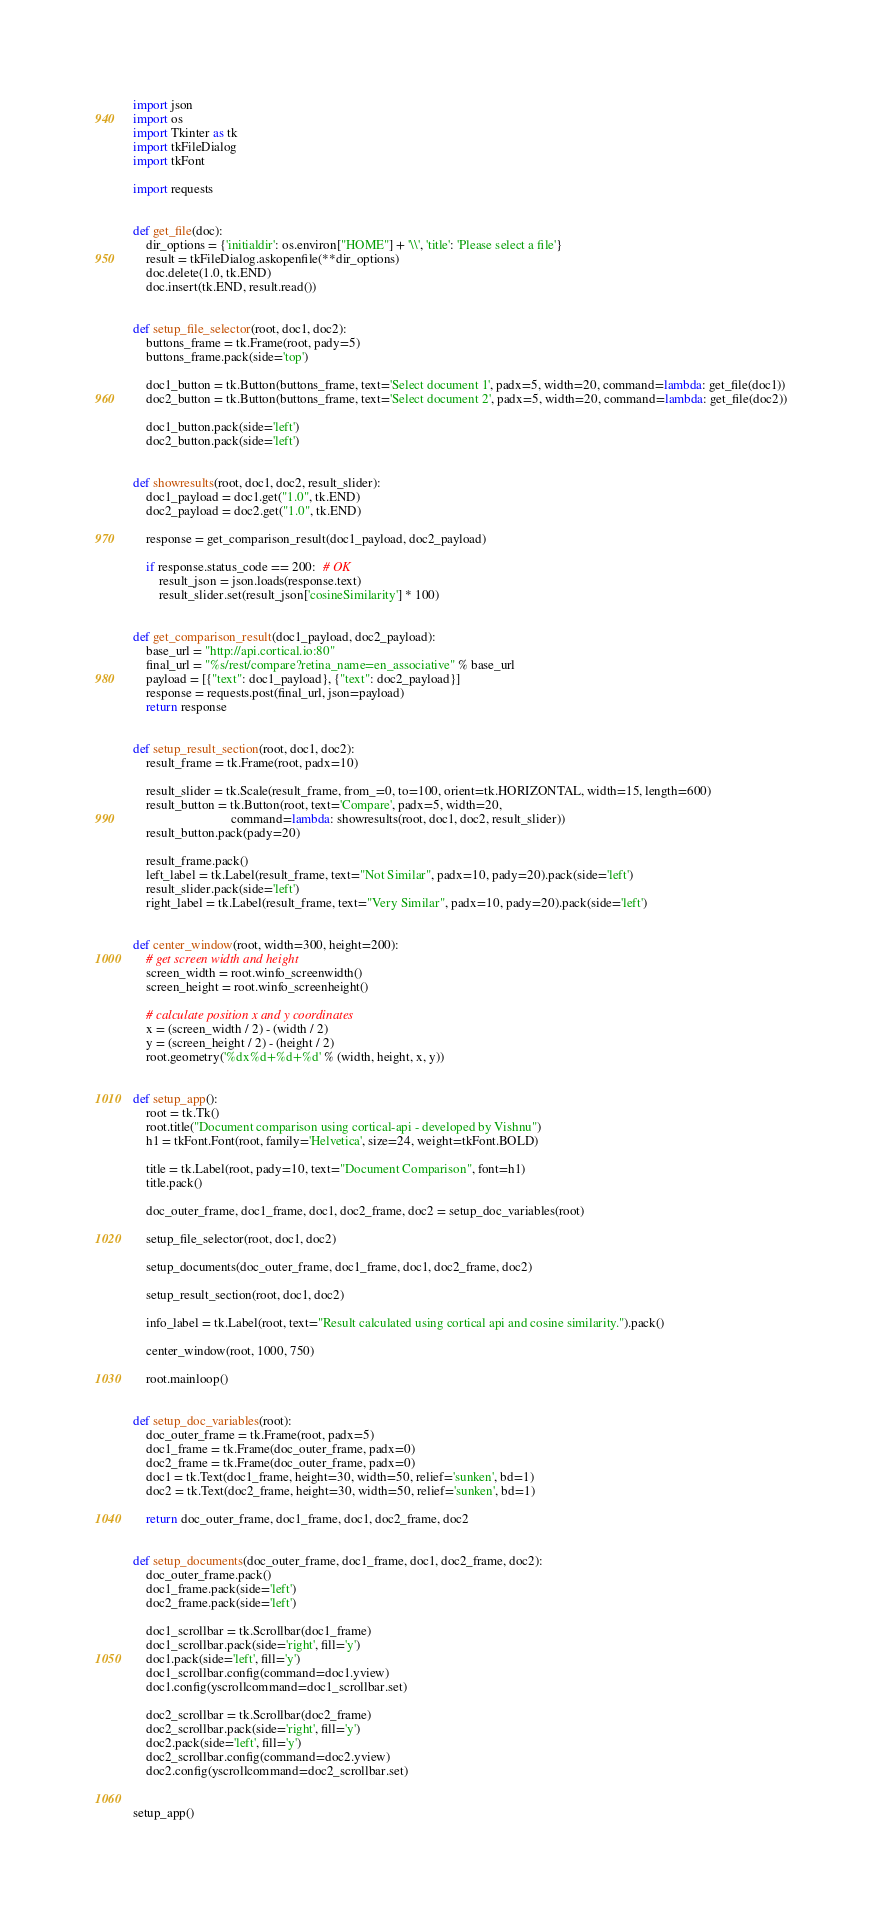<code> <loc_0><loc_0><loc_500><loc_500><_Python_>import json
import os
import Tkinter as tk
import tkFileDialog
import tkFont

import requests


def get_file(doc):
    dir_options = {'initialdir': os.environ["HOME"] + '\\', 'title': 'Please select a file'}
    result = tkFileDialog.askopenfile(**dir_options)
    doc.delete(1.0, tk.END)
    doc.insert(tk.END, result.read())


def setup_file_selector(root, doc1, doc2):
    buttons_frame = tk.Frame(root, pady=5)
    buttons_frame.pack(side='top')

    doc1_button = tk.Button(buttons_frame, text='Select document 1', padx=5, width=20, command=lambda: get_file(doc1))
    doc2_button = tk.Button(buttons_frame, text='Select document 2', padx=5, width=20, command=lambda: get_file(doc2))

    doc1_button.pack(side='left')
    doc2_button.pack(side='left')


def showresults(root, doc1, doc2, result_slider):
    doc1_payload = doc1.get("1.0", tk.END)
    doc2_payload = doc2.get("1.0", tk.END)

    response = get_comparison_result(doc1_payload, doc2_payload)

    if response.status_code == 200:  # OK
        result_json = json.loads(response.text)
        result_slider.set(result_json['cosineSimilarity'] * 100)


def get_comparison_result(doc1_payload, doc2_payload):
    base_url = "http://api.cortical.io:80"
    final_url = "%s/rest/compare?retina_name=en_associative" % base_url
    payload = [{"text": doc1_payload}, {"text": doc2_payload}]
    response = requests.post(final_url, json=payload)
    return response


def setup_result_section(root, doc1, doc2):
    result_frame = tk.Frame(root, padx=10)

    result_slider = tk.Scale(result_frame, from_=0, to=100, orient=tk.HORIZONTAL, width=15, length=600)
    result_button = tk.Button(root, text='Compare', padx=5, width=20,
                              command=lambda: showresults(root, doc1, doc2, result_slider))
    result_button.pack(pady=20)

    result_frame.pack()
    left_label = tk.Label(result_frame, text="Not Similar", padx=10, pady=20).pack(side='left')
    result_slider.pack(side='left')
    right_label = tk.Label(result_frame, text="Very Similar", padx=10, pady=20).pack(side='left')


def center_window(root, width=300, height=200):
    # get screen width and height
    screen_width = root.winfo_screenwidth()
    screen_height = root.winfo_screenheight()

    # calculate position x and y coordinates
    x = (screen_width / 2) - (width / 2)
    y = (screen_height / 2) - (height / 2)
    root.geometry('%dx%d+%d+%d' % (width, height, x, y))


def setup_app():
    root = tk.Tk()
    root.title("Document comparison using cortical-api - developed by Vishnu")
    h1 = tkFont.Font(root, family='Helvetica', size=24, weight=tkFont.BOLD)

    title = tk.Label(root, pady=10, text="Document Comparison", font=h1)
    title.pack()

    doc_outer_frame, doc1_frame, doc1, doc2_frame, doc2 = setup_doc_variables(root)

    setup_file_selector(root, doc1, doc2)

    setup_documents(doc_outer_frame, doc1_frame, doc1, doc2_frame, doc2)

    setup_result_section(root, doc1, doc2)

    info_label = tk.Label(root, text="Result calculated using cortical api and cosine similarity.").pack()

    center_window(root, 1000, 750)

    root.mainloop()


def setup_doc_variables(root):
    doc_outer_frame = tk.Frame(root, padx=5)
    doc1_frame = tk.Frame(doc_outer_frame, padx=0)
    doc2_frame = tk.Frame(doc_outer_frame, padx=0)
    doc1 = tk.Text(doc1_frame, height=30, width=50, relief='sunken', bd=1)
    doc2 = tk.Text(doc2_frame, height=30, width=50, relief='sunken', bd=1)

    return doc_outer_frame, doc1_frame, doc1, doc2_frame, doc2


def setup_documents(doc_outer_frame, doc1_frame, doc1, doc2_frame, doc2):
    doc_outer_frame.pack()
    doc1_frame.pack(side='left')
    doc2_frame.pack(side='left')

    doc1_scrollbar = tk.Scrollbar(doc1_frame)
    doc1_scrollbar.pack(side='right', fill='y')
    doc1.pack(side='left', fill='y')
    doc1_scrollbar.config(command=doc1.yview)
    doc1.config(yscrollcommand=doc1_scrollbar.set)

    doc2_scrollbar = tk.Scrollbar(doc2_frame)
    doc2_scrollbar.pack(side='right', fill='y')
    doc2.pack(side='left', fill='y')
    doc2_scrollbar.config(command=doc2.yview)
    doc2.config(yscrollcommand=doc2_scrollbar.set)


setup_app()
</code> 